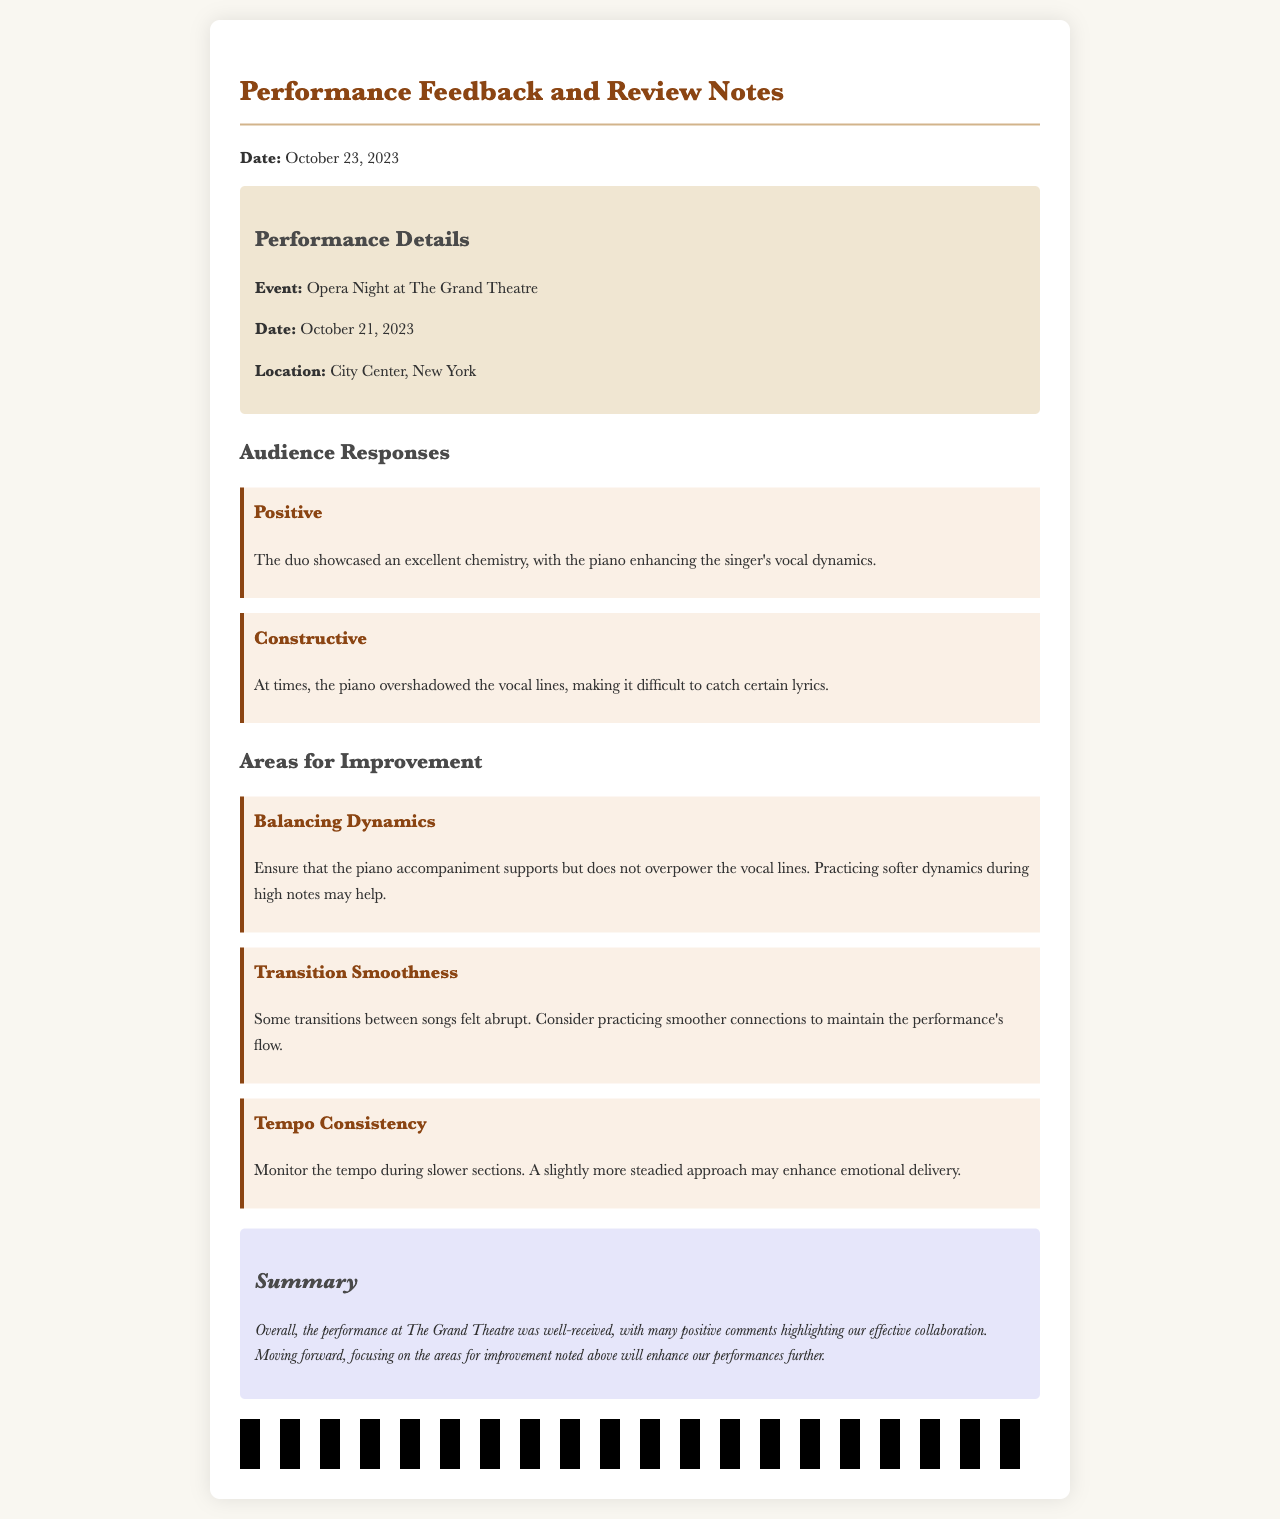what was the date of the performance? The performance took place on October 21, 2023, as stated in the performance details section.
Answer: October 21, 2023 what was the location of the event? The document mentions the location as City Center, New York.
Answer: City Center, New York what feedback did the audience give regarding the duo's chemistry? The audience positively noted that the duo showcased excellent chemistry.
Answer: Excellent chemistry how many areas for improvement are listed? The document lists three areas for improvement under the respective section.
Answer: Three what is one specific recommendation for balancing dynamics? The document suggests practicing softer dynamics during high notes to ensure the piano does not overpower the vocals.
Answer: Softer dynamics during high notes what is the overall summary of the performance? The summary highlights that the performance was well-received and emphasizes focusing on areas for improvement.
Answer: Well-received which performance aspect was noted to feel abrupt? The transitions between songs were highlighted as feeling abrupt during the performance.
Answer: Transitions what date was the feedback document created? The feedback document was created on October 23, 2023, as noted at the beginning.
Answer: October 23, 2023 